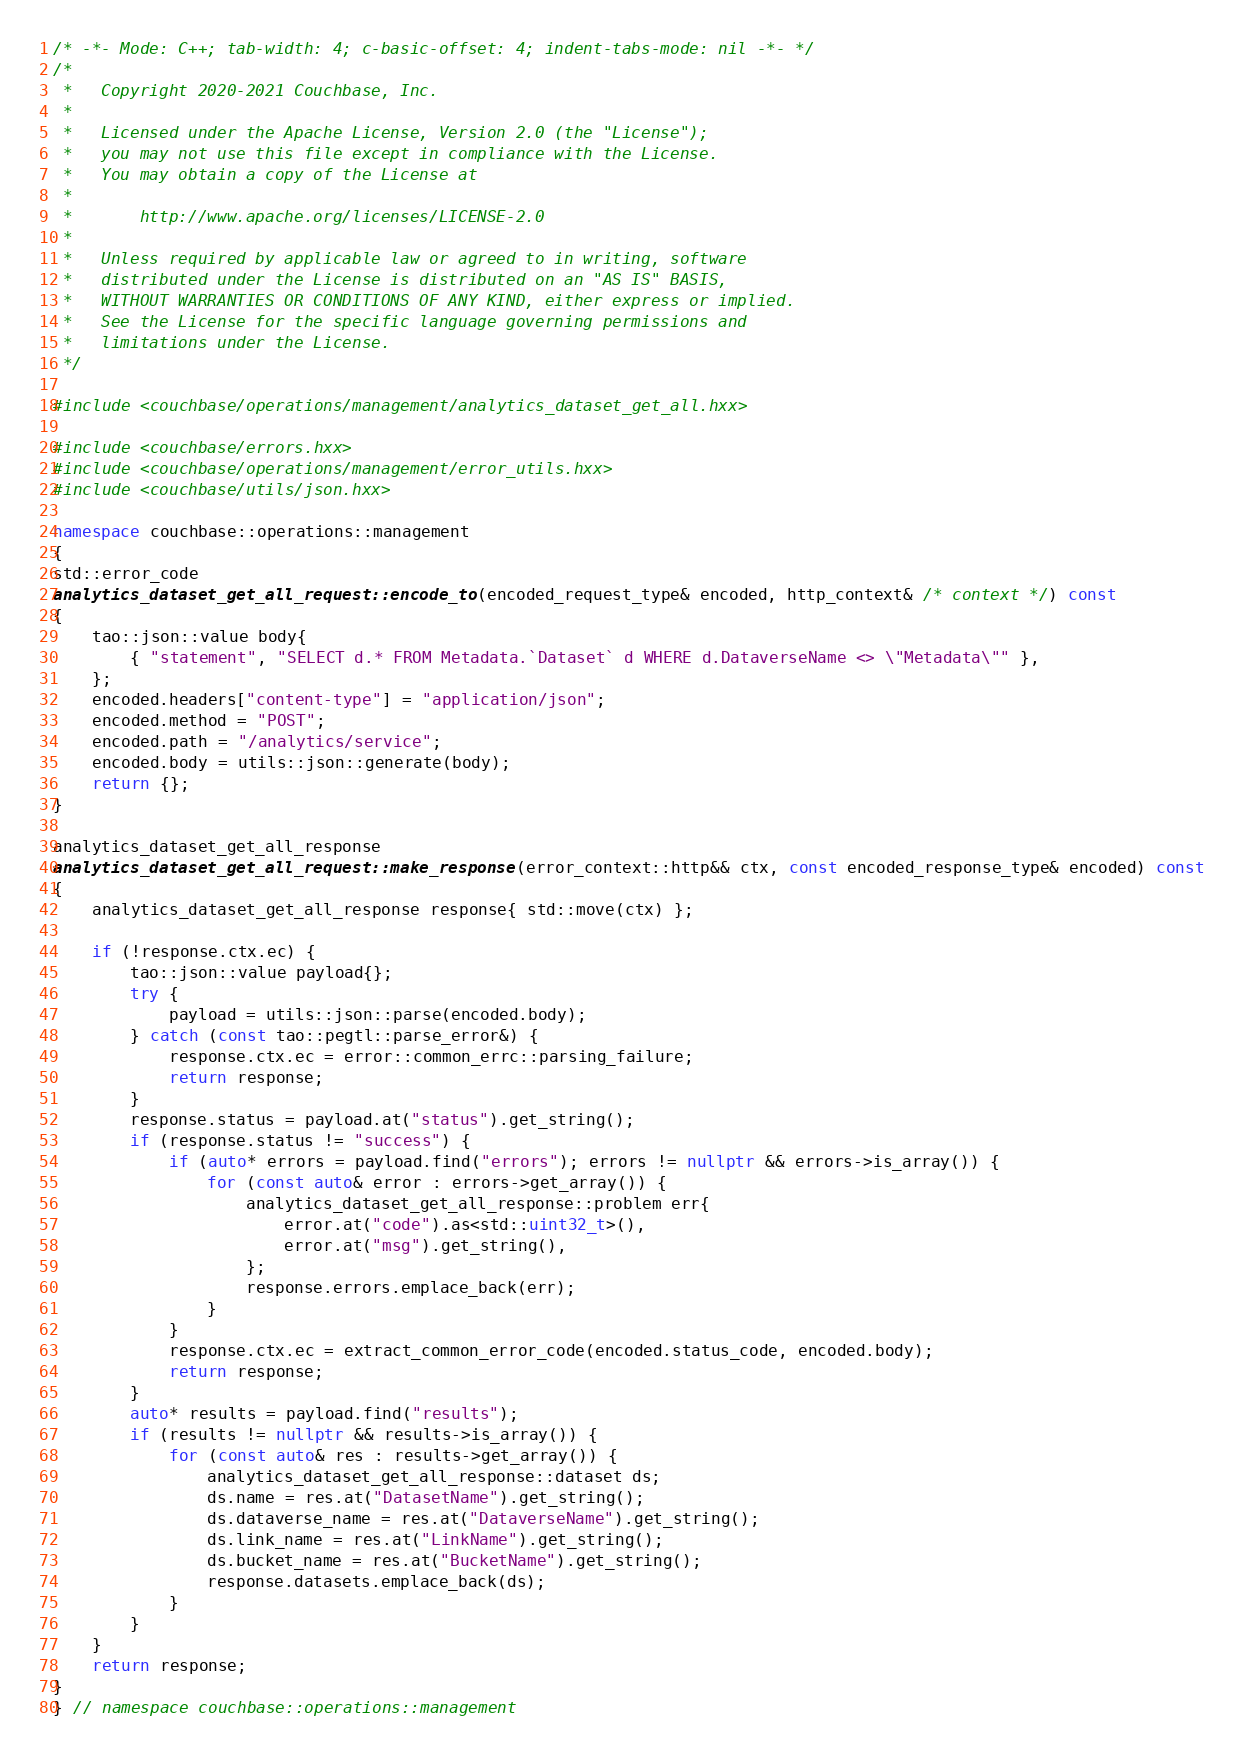Convert code to text. <code><loc_0><loc_0><loc_500><loc_500><_C++_>/* -*- Mode: C++; tab-width: 4; c-basic-offset: 4; indent-tabs-mode: nil -*- */
/*
 *   Copyright 2020-2021 Couchbase, Inc.
 *
 *   Licensed under the Apache License, Version 2.0 (the "License");
 *   you may not use this file except in compliance with the License.
 *   You may obtain a copy of the License at
 *
 *       http://www.apache.org/licenses/LICENSE-2.0
 *
 *   Unless required by applicable law or agreed to in writing, software
 *   distributed under the License is distributed on an "AS IS" BASIS,
 *   WITHOUT WARRANTIES OR CONDITIONS OF ANY KIND, either express or implied.
 *   See the License for the specific language governing permissions and
 *   limitations under the License.
 */

#include <couchbase/operations/management/analytics_dataset_get_all.hxx>

#include <couchbase/errors.hxx>
#include <couchbase/operations/management/error_utils.hxx>
#include <couchbase/utils/json.hxx>

namespace couchbase::operations::management
{
std::error_code
analytics_dataset_get_all_request::encode_to(encoded_request_type& encoded, http_context& /* context */) const
{
    tao::json::value body{
        { "statement", "SELECT d.* FROM Metadata.`Dataset` d WHERE d.DataverseName <> \"Metadata\"" },
    };
    encoded.headers["content-type"] = "application/json";
    encoded.method = "POST";
    encoded.path = "/analytics/service";
    encoded.body = utils::json::generate(body);
    return {};
}

analytics_dataset_get_all_response
analytics_dataset_get_all_request::make_response(error_context::http&& ctx, const encoded_response_type& encoded) const
{
    analytics_dataset_get_all_response response{ std::move(ctx) };

    if (!response.ctx.ec) {
        tao::json::value payload{};
        try {
            payload = utils::json::parse(encoded.body);
        } catch (const tao::pegtl::parse_error&) {
            response.ctx.ec = error::common_errc::parsing_failure;
            return response;
        }
        response.status = payload.at("status").get_string();
        if (response.status != "success") {
            if (auto* errors = payload.find("errors"); errors != nullptr && errors->is_array()) {
                for (const auto& error : errors->get_array()) {
                    analytics_dataset_get_all_response::problem err{
                        error.at("code").as<std::uint32_t>(),
                        error.at("msg").get_string(),
                    };
                    response.errors.emplace_back(err);
                }
            }
            response.ctx.ec = extract_common_error_code(encoded.status_code, encoded.body);
            return response;
        }
        auto* results = payload.find("results");
        if (results != nullptr && results->is_array()) {
            for (const auto& res : results->get_array()) {
                analytics_dataset_get_all_response::dataset ds;
                ds.name = res.at("DatasetName").get_string();
                ds.dataverse_name = res.at("DataverseName").get_string();
                ds.link_name = res.at("LinkName").get_string();
                ds.bucket_name = res.at("BucketName").get_string();
                response.datasets.emplace_back(ds);
            }
        }
    }
    return response;
}
} // namespace couchbase::operations::management
</code> 